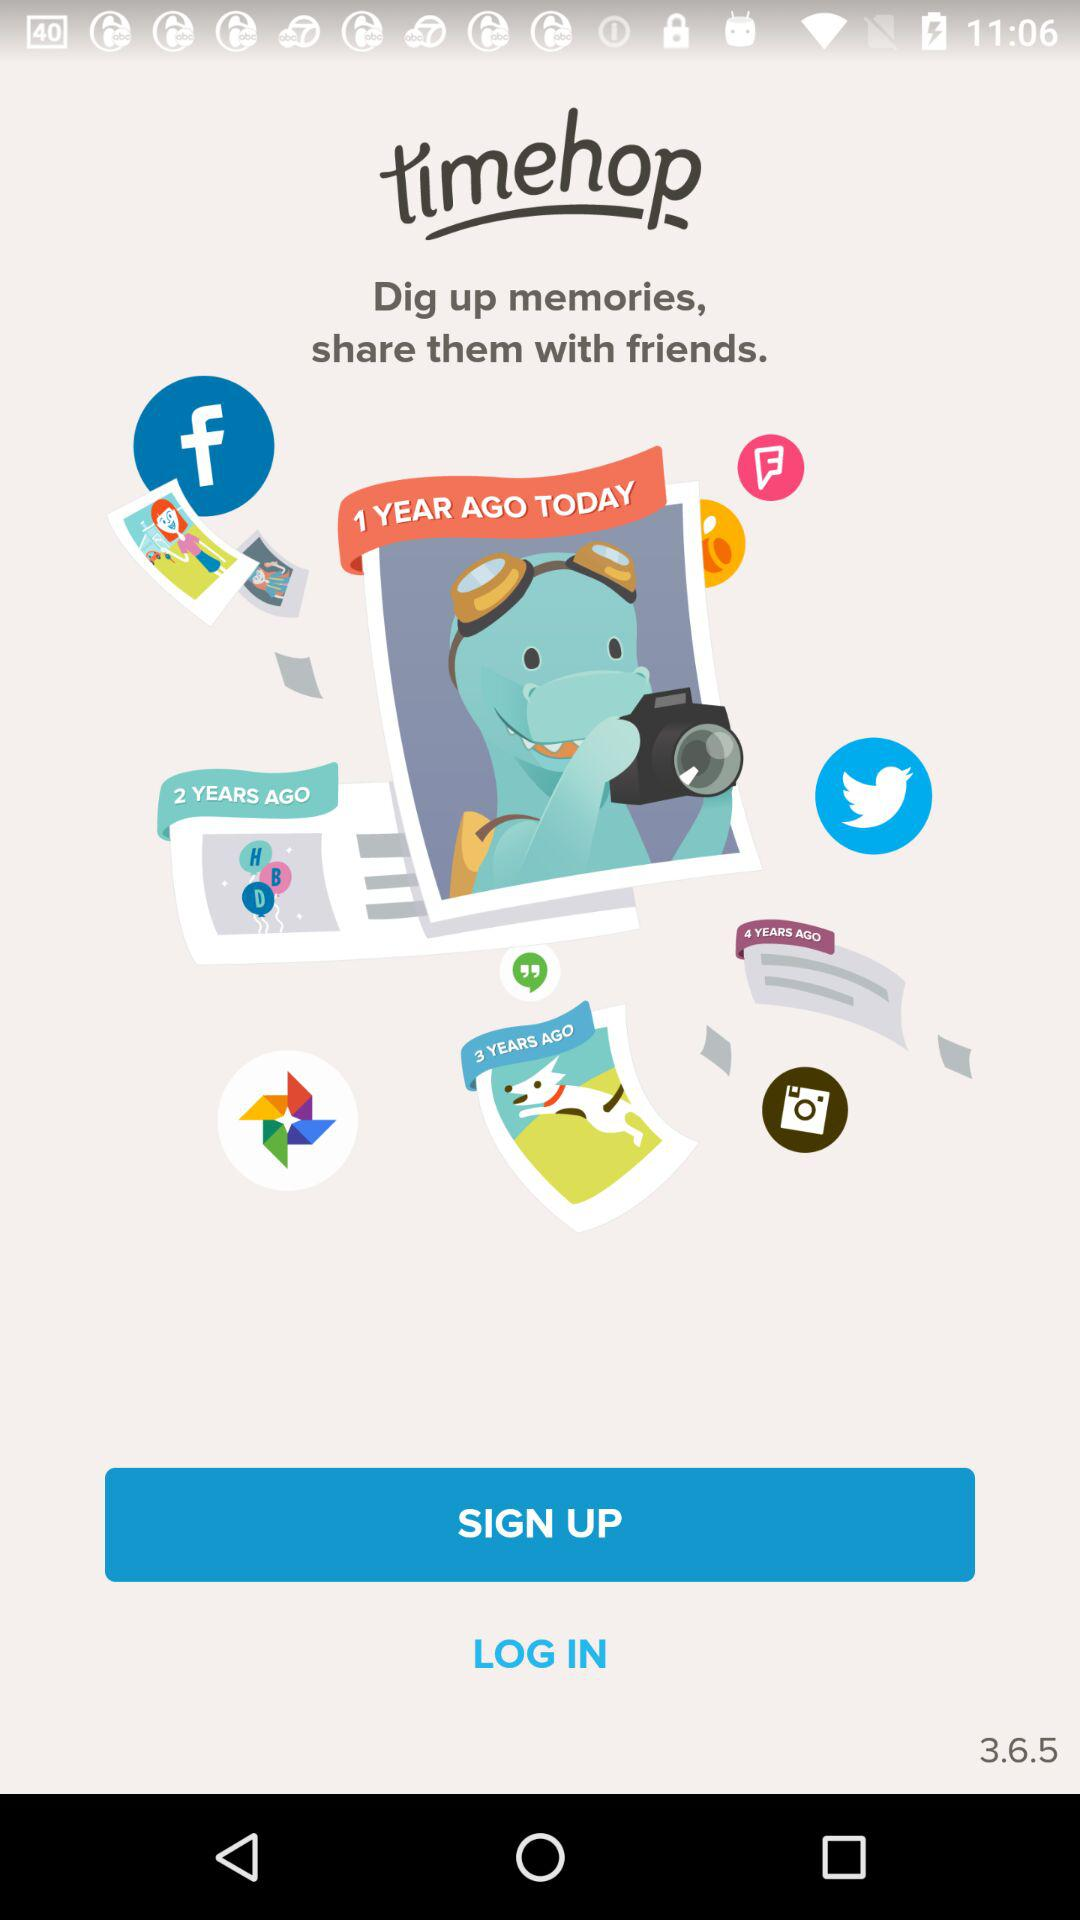What is the version? The version is 3.6.5. 